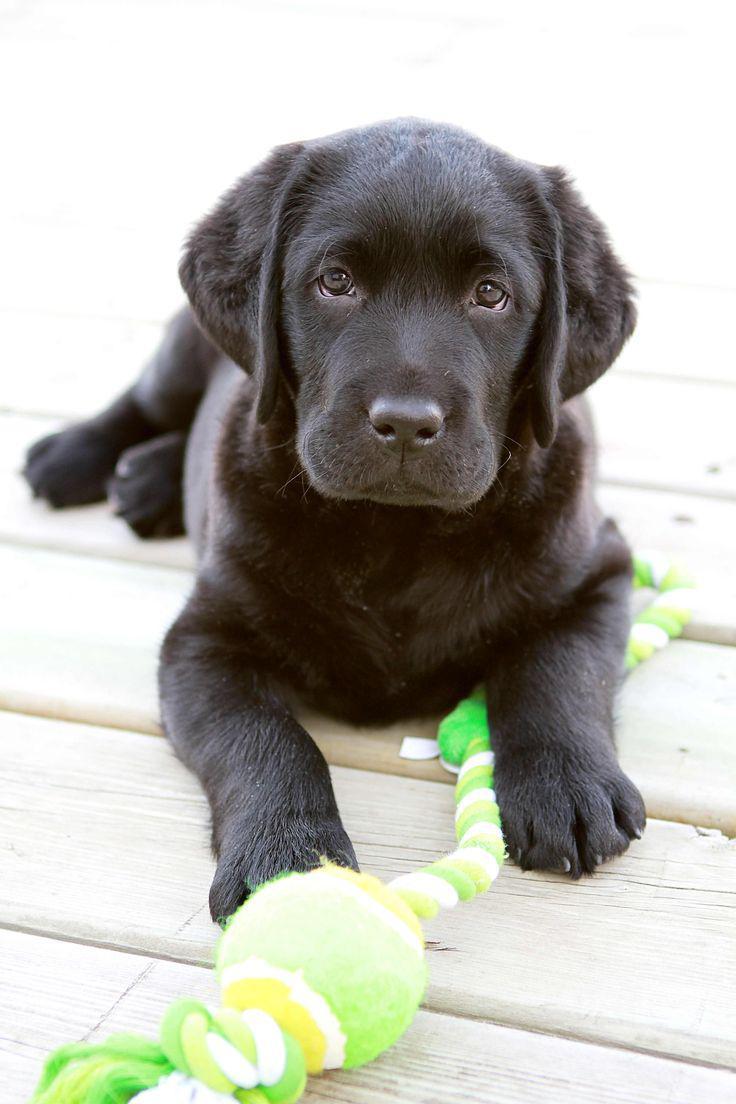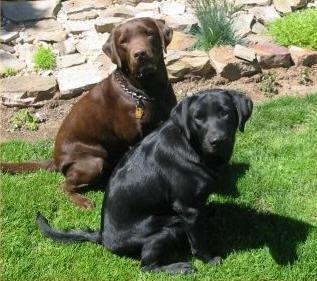The first image is the image on the left, the second image is the image on the right. Assess this claim about the two images: "One picture shows a brown dog, a light cream dog, and a black dog next to each other, with the light dog in the middle.". Correct or not? Answer yes or no. No. The first image is the image on the left, the second image is the image on the right. For the images displayed, is the sentence "There are the same number of dogs in each image, but they are a different age in one image than the other." factually correct? Answer yes or no. No. 